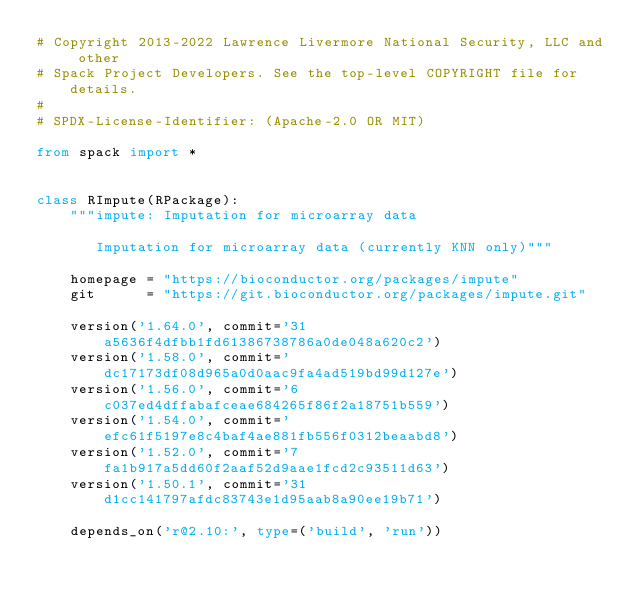Convert code to text. <code><loc_0><loc_0><loc_500><loc_500><_Python_># Copyright 2013-2022 Lawrence Livermore National Security, LLC and other
# Spack Project Developers. See the top-level COPYRIGHT file for details.
#
# SPDX-License-Identifier: (Apache-2.0 OR MIT)

from spack import *


class RImpute(RPackage):
    """impute: Imputation for microarray data

       Imputation for microarray data (currently KNN only)"""

    homepage = "https://bioconductor.org/packages/impute"
    git      = "https://git.bioconductor.org/packages/impute.git"

    version('1.64.0', commit='31a5636f4dfbb1fd61386738786a0de048a620c2')
    version('1.58.0', commit='dc17173df08d965a0d0aac9fa4ad519bd99d127e')
    version('1.56.0', commit='6c037ed4dffabafceae684265f86f2a18751b559')
    version('1.54.0', commit='efc61f5197e8c4baf4ae881fb556f0312beaabd8')
    version('1.52.0', commit='7fa1b917a5dd60f2aaf52d9aae1fcd2c93511d63')
    version('1.50.1', commit='31d1cc141797afdc83743e1d95aab8a90ee19b71')

    depends_on('r@2.10:', type=('build', 'run'))
</code> 